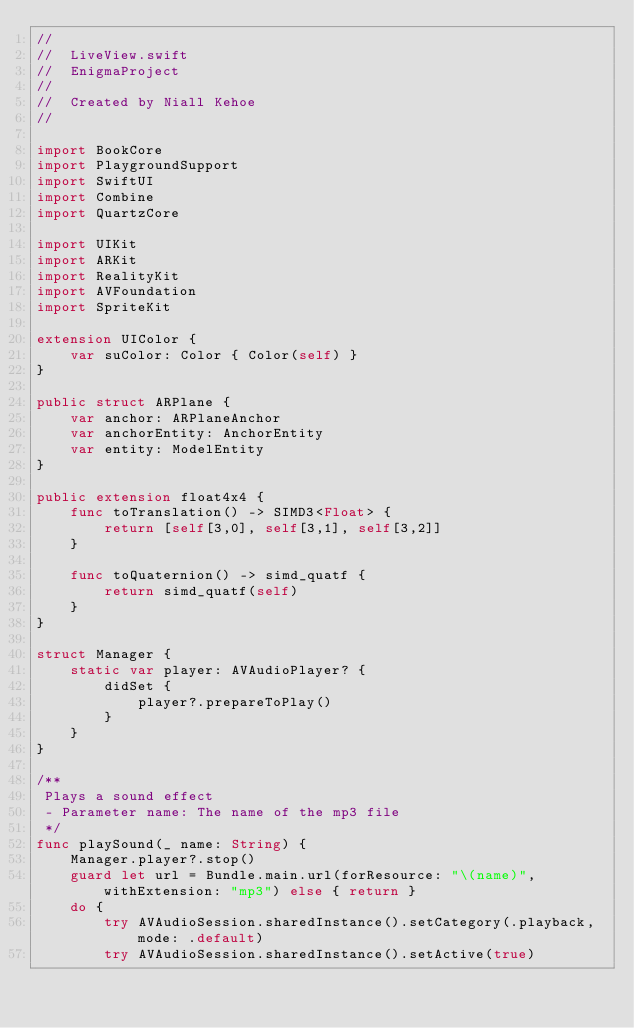Convert code to text. <code><loc_0><loc_0><loc_500><loc_500><_Swift_>//
//  LiveView.swift
//  EnigmaProject
//
//  Created by Niall Kehoe
//

import BookCore
import PlaygroundSupport
import SwiftUI
import Combine
import QuartzCore

import UIKit
import ARKit
import RealityKit
import AVFoundation
import SpriteKit

extension UIColor {
    var suColor: Color { Color(self) }
}

public struct ARPlane {
    var anchor: ARPlaneAnchor
    var anchorEntity: AnchorEntity
    var entity: ModelEntity
}

public extension float4x4 {
    func toTranslation() -> SIMD3<Float> {
        return [self[3,0], self[3,1], self[3,2]]
    }

    func toQuaternion() -> simd_quatf {
        return simd_quatf(self)
    }
}

struct Manager {
    static var player: AVAudioPlayer? {
        didSet {
            player?.prepareToPlay()
        }
    }
}

/**
 Plays a sound effect
 - Parameter name: The name of the mp3 file
 */
func playSound(_ name: String) {
    Manager.player?.stop()
    guard let url = Bundle.main.url(forResource: "\(name)", withExtension: "mp3") else { return }
    do {
        try AVAudioSession.sharedInstance().setCategory(.playback, mode: .default)
        try AVAudioSession.sharedInstance().setActive(true)
</code> 